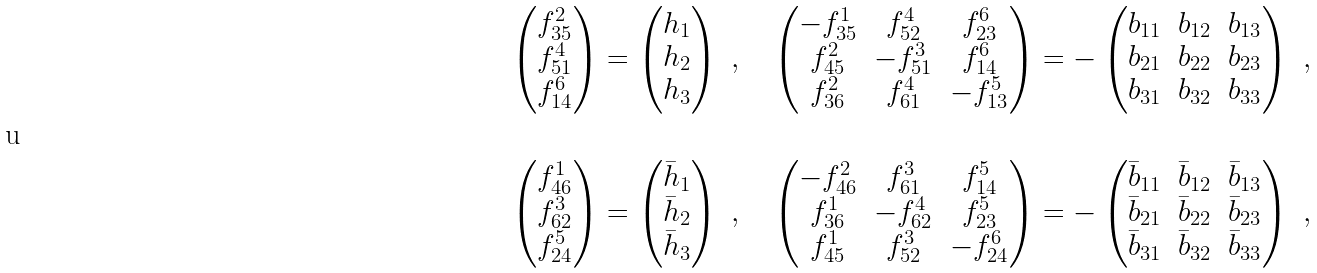Convert formula to latex. <formula><loc_0><loc_0><loc_500><loc_500>& \begin{pmatrix} f ^ { 2 } _ { 3 5 } \\ f ^ { 4 } _ { 5 1 } \\ f ^ { 6 } _ { 1 4 } \end{pmatrix} = \begin{pmatrix} h _ { 1 } \\ h _ { 2 } \\ h _ { 3 } \end{pmatrix} \ , \quad \begin{pmatrix} - f ^ { 1 } _ { 3 5 } & f ^ { 4 } _ { 5 2 } & f ^ { 6 } _ { 2 3 } \\ f ^ { 2 } _ { 4 5 } & - f ^ { 3 } _ { 5 1 } & f ^ { 6 } _ { 1 4 } \\ f ^ { 2 } _ { 3 6 } & f ^ { 4 } _ { 6 1 } & - f ^ { 5 } _ { 1 3 } \end{pmatrix} = - \begin{pmatrix} b _ { 1 1 } & b _ { 1 2 } & b _ { 1 3 } \\ b _ { 2 1 } & b _ { 2 2 } & b _ { 2 3 } \\ b _ { 3 1 } & b _ { 3 2 } & b _ { 3 3 } \end{pmatrix} \ , \\ \\ & \begin{pmatrix} f ^ { 1 } _ { 4 6 } \\ f ^ { 3 } _ { 6 2 } \\ f ^ { 5 } _ { 2 4 } \end{pmatrix} = \begin{pmatrix} \bar { h } _ { 1 } \\ \bar { h } _ { 2 } \\ \bar { h } _ { 3 } \end{pmatrix} \ , \quad \begin{pmatrix} - f ^ { 2 } _ { 4 6 } & f ^ { 3 } _ { 6 1 } & f ^ { 5 } _ { 1 4 } \\ f ^ { 1 } _ { 3 6 } & - f ^ { 4 } _ { 6 2 } & f ^ { 5 } _ { 2 3 } \\ f ^ { 1 } _ { 4 5 } & f ^ { 3 } _ { 5 2 } & - f ^ { 6 } _ { 2 4 } \end{pmatrix} = - \begin{pmatrix} \bar { b } _ { 1 1 } & \bar { b } _ { 1 2 } & \bar { b } _ { 1 3 } \\ \bar { b } _ { 2 1 } & \bar { b } _ { 2 2 } & \bar { b } _ { 2 3 } \\ \bar { b } _ { 3 1 } & \bar { b } _ { 3 2 } & \bar { b } _ { 3 3 } \end{pmatrix} \ ,</formula> 